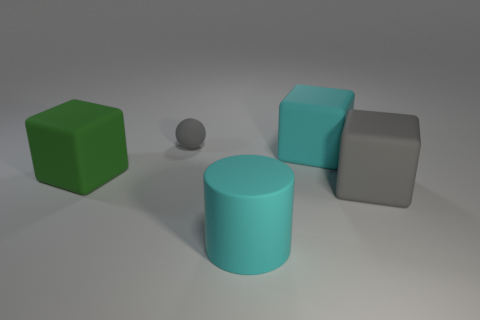Subtract all large green matte blocks. How many blocks are left? 2 Add 1 large green metal cylinders. How many objects exist? 6 Subtract 1 cylinders. How many cylinders are left? 0 Subtract all green cylinders. How many blue balls are left? 0 Subtract all spheres. How many objects are left? 4 Subtract all purple spheres. Subtract all cyan cubes. How many spheres are left? 1 Add 5 large rubber cubes. How many large rubber cubes are left? 8 Add 5 blue rubber balls. How many blue rubber balls exist? 5 Subtract 0 purple spheres. How many objects are left? 5 Subtract all large objects. Subtract all green objects. How many objects are left? 0 